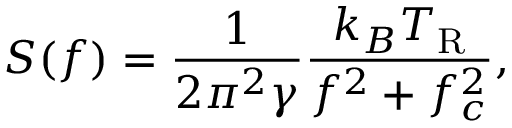<formula> <loc_0><loc_0><loc_500><loc_500>S ( f ) = \frac { 1 } { 2 \pi ^ { 2 } \gamma } \frac { k _ { B } T _ { R } } { f ^ { 2 } + f _ { c } ^ { 2 } } ,</formula> 